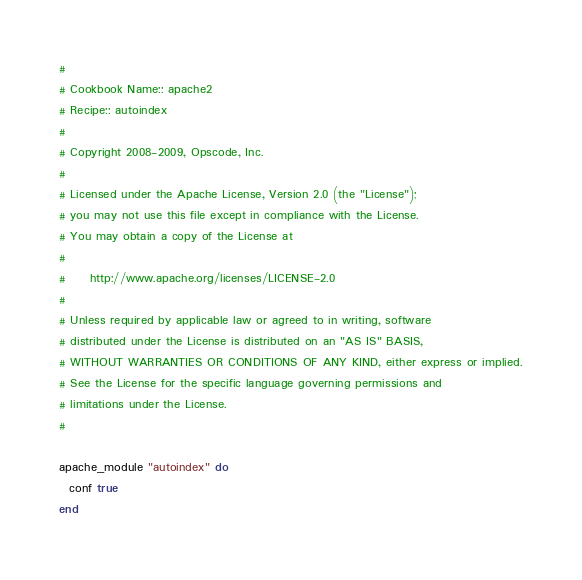Convert code to text. <code><loc_0><loc_0><loc_500><loc_500><_Ruby_>#
# Cookbook Name:: apache2
# Recipe:: autoindex 
#
# Copyright 2008-2009, Opscode, Inc.
#
# Licensed under the Apache License, Version 2.0 (the "License");
# you may not use this file except in compliance with the License.
# You may obtain a copy of the License at
#
#     http://www.apache.org/licenses/LICENSE-2.0
#
# Unless required by applicable law or agreed to in writing, software
# distributed under the License is distributed on an "AS IS" BASIS,
# WITHOUT WARRANTIES OR CONDITIONS OF ANY KIND, either express or implied.
# See the License for the specific language governing permissions and
# limitations under the License.
#

apache_module "autoindex" do
  conf true
end
</code> 